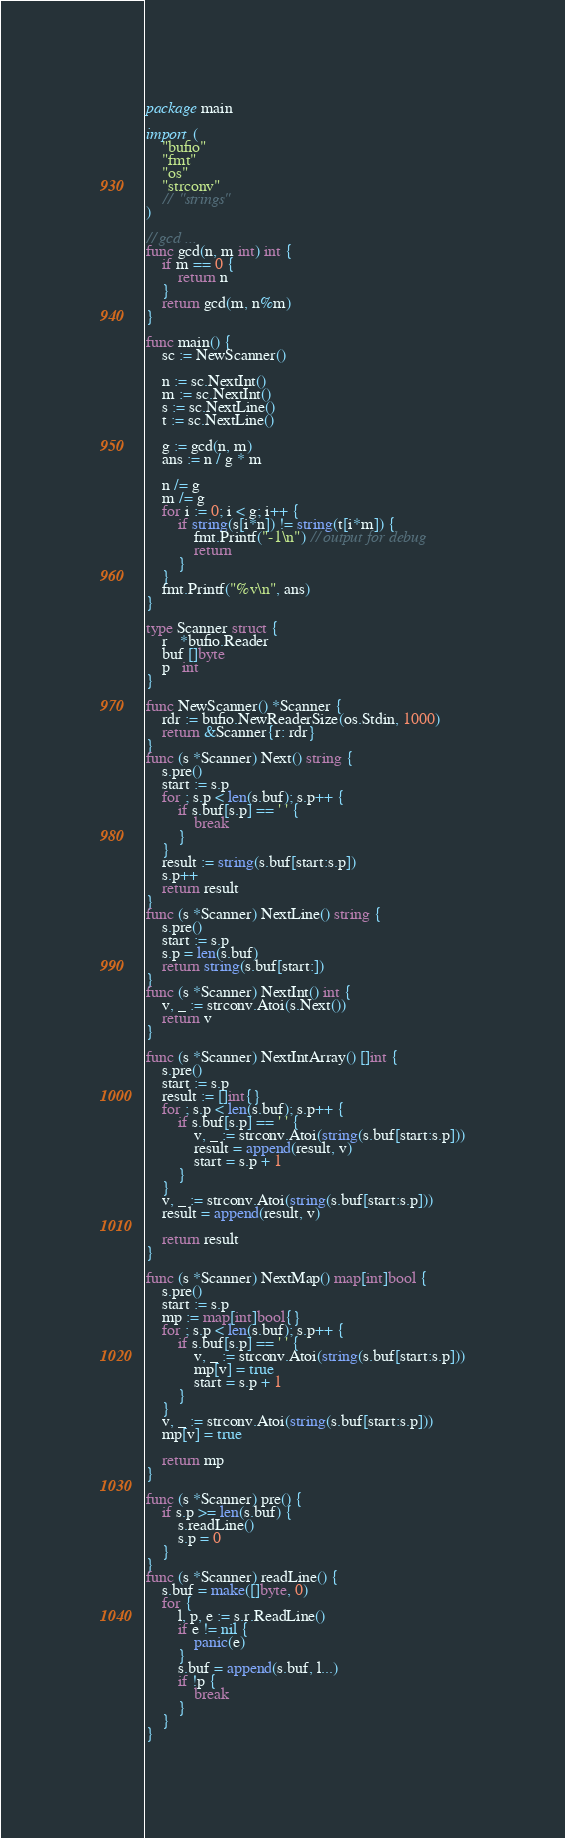<code> <loc_0><loc_0><loc_500><loc_500><_Go_>package main

import (
	"bufio"
	"fmt"
	"os"
	"strconv"
	//	"strings"
)

// gcd ...
func gcd(n, m int) int {
	if m == 0 {
		return n
	}
	return gcd(m, n%m)
}

func main() {
	sc := NewScanner()

	n := sc.NextInt()
	m := sc.NextInt()
	s := sc.NextLine()
	t := sc.NextLine()

	g := gcd(n, m)
	ans := n / g * m

	n /= g
	m /= g
	for i := 0; i < g; i++ {
		if string(s[i*n]) != string(t[i*m]) {
			fmt.Printf("-1\n") // output for debug
			return
		}
	}
	fmt.Printf("%v\n", ans)
}

type Scanner struct {
	r   *bufio.Reader
	buf []byte
	p   int
}

func NewScanner() *Scanner {
	rdr := bufio.NewReaderSize(os.Stdin, 1000)
	return &Scanner{r: rdr}
}
func (s *Scanner) Next() string {
	s.pre()
	start := s.p
	for ; s.p < len(s.buf); s.p++ {
		if s.buf[s.p] == ' ' {
			break
		}
	}
	result := string(s.buf[start:s.p])
	s.p++
	return result
}
func (s *Scanner) NextLine() string {
	s.pre()
	start := s.p
	s.p = len(s.buf)
	return string(s.buf[start:])
}
func (s *Scanner) NextInt() int {
	v, _ := strconv.Atoi(s.Next())
	return v
}

func (s *Scanner) NextIntArray() []int {
	s.pre()
	start := s.p
	result := []int{}
	for ; s.p < len(s.buf); s.p++ {
		if s.buf[s.p] == ' ' {
			v, _ := strconv.Atoi(string(s.buf[start:s.p]))
			result = append(result, v)
			start = s.p + 1
		}
	}
	v, _ := strconv.Atoi(string(s.buf[start:s.p]))
	result = append(result, v)

	return result
}

func (s *Scanner) NextMap() map[int]bool {
	s.pre()
	start := s.p
	mp := map[int]bool{}
	for ; s.p < len(s.buf); s.p++ {
		if s.buf[s.p] == ' ' {
			v, _ := strconv.Atoi(string(s.buf[start:s.p]))
			mp[v] = true
			start = s.p + 1
		}
	}
	v, _ := strconv.Atoi(string(s.buf[start:s.p]))
	mp[v] = true

	return mp
}

func (s *Scanner) pre() {
	if s.p >= len(s.buf) {
		s.readLine()
		s.p = 0
	}
}
func (s *Scanner) readLine() {
	s.buf = make([]byte, 0)
	for {
		l, p, e := s.r.ReadLine()
		if e != nil {
			panic(e)
		}
		s.buf = append(s.buf, l...)
		if !p {
			break
		}
	}
}
</code> 